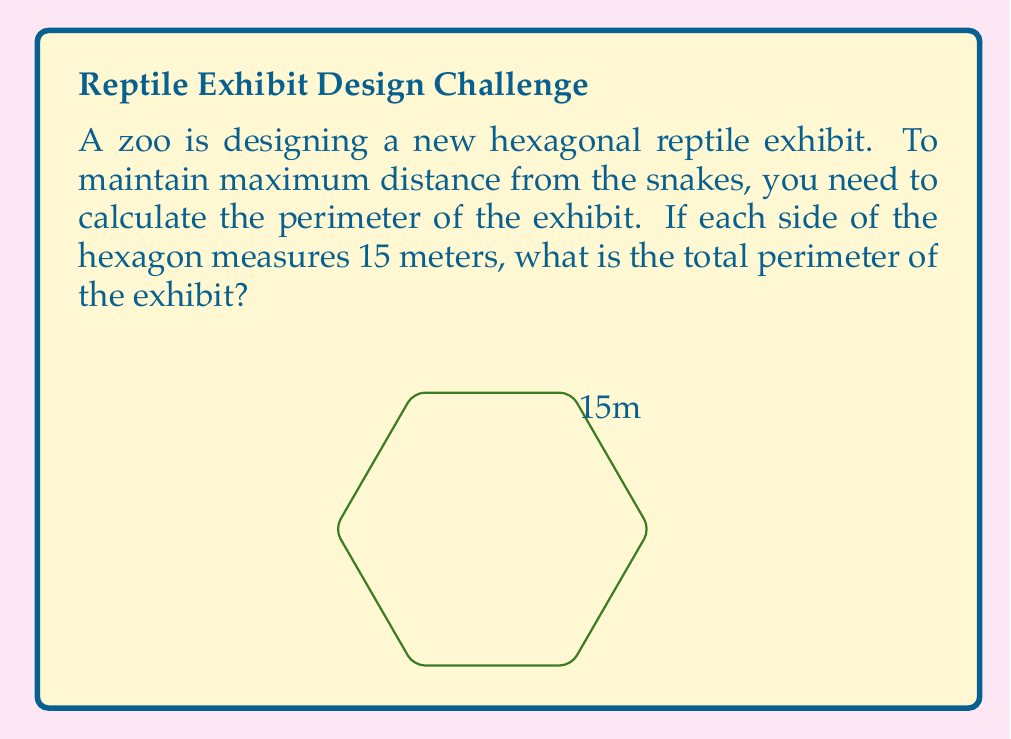What is the answer to this math problem? To calculate the perimeter of a regular hexagon, we need to:

1. Identify the length of one side: $s = 15$ meters

2. Recall that a hexagon has 6 equal sides

3. Use the formula for the perimeter of a regular polygon:
   $P = ns$, where $n$ is the number of sides and $s$ is the length of one side

4. Substitute the values:
   $P = 6 \cdot 15$

5. Perform the calculation:
   $P = 90$ meters

Therefore, the perimeter of the hexagonal reptile exhibit is 90 meters. This distance ensures you can maintain the maximum possible distance from the snakes while observing the exhibit.
Answer: 90 meters 